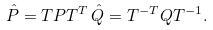Convert formula to latex. <formula><loc_0><loc_0><loc_500><loc_500>\hat { P } = T P T ^ { T } \, \hat { Q } = T ^ { - T } Q T ^ { - 1 } .</formula> 